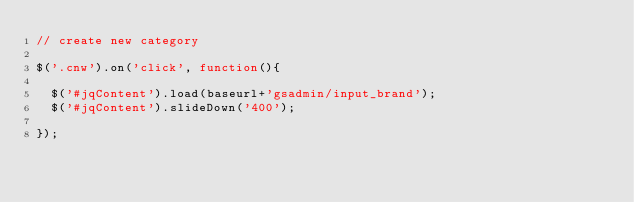Convert code to text. <code><loc_0><loc_0><loc_500><loc_500><_JavaScript_>// create new category

$('.cnw').on('click', function(){

	$('#jqContent').load(baseurl+'gsadmin/input_brand');
	$('#jqContent').slideDown('400');

});</code> 